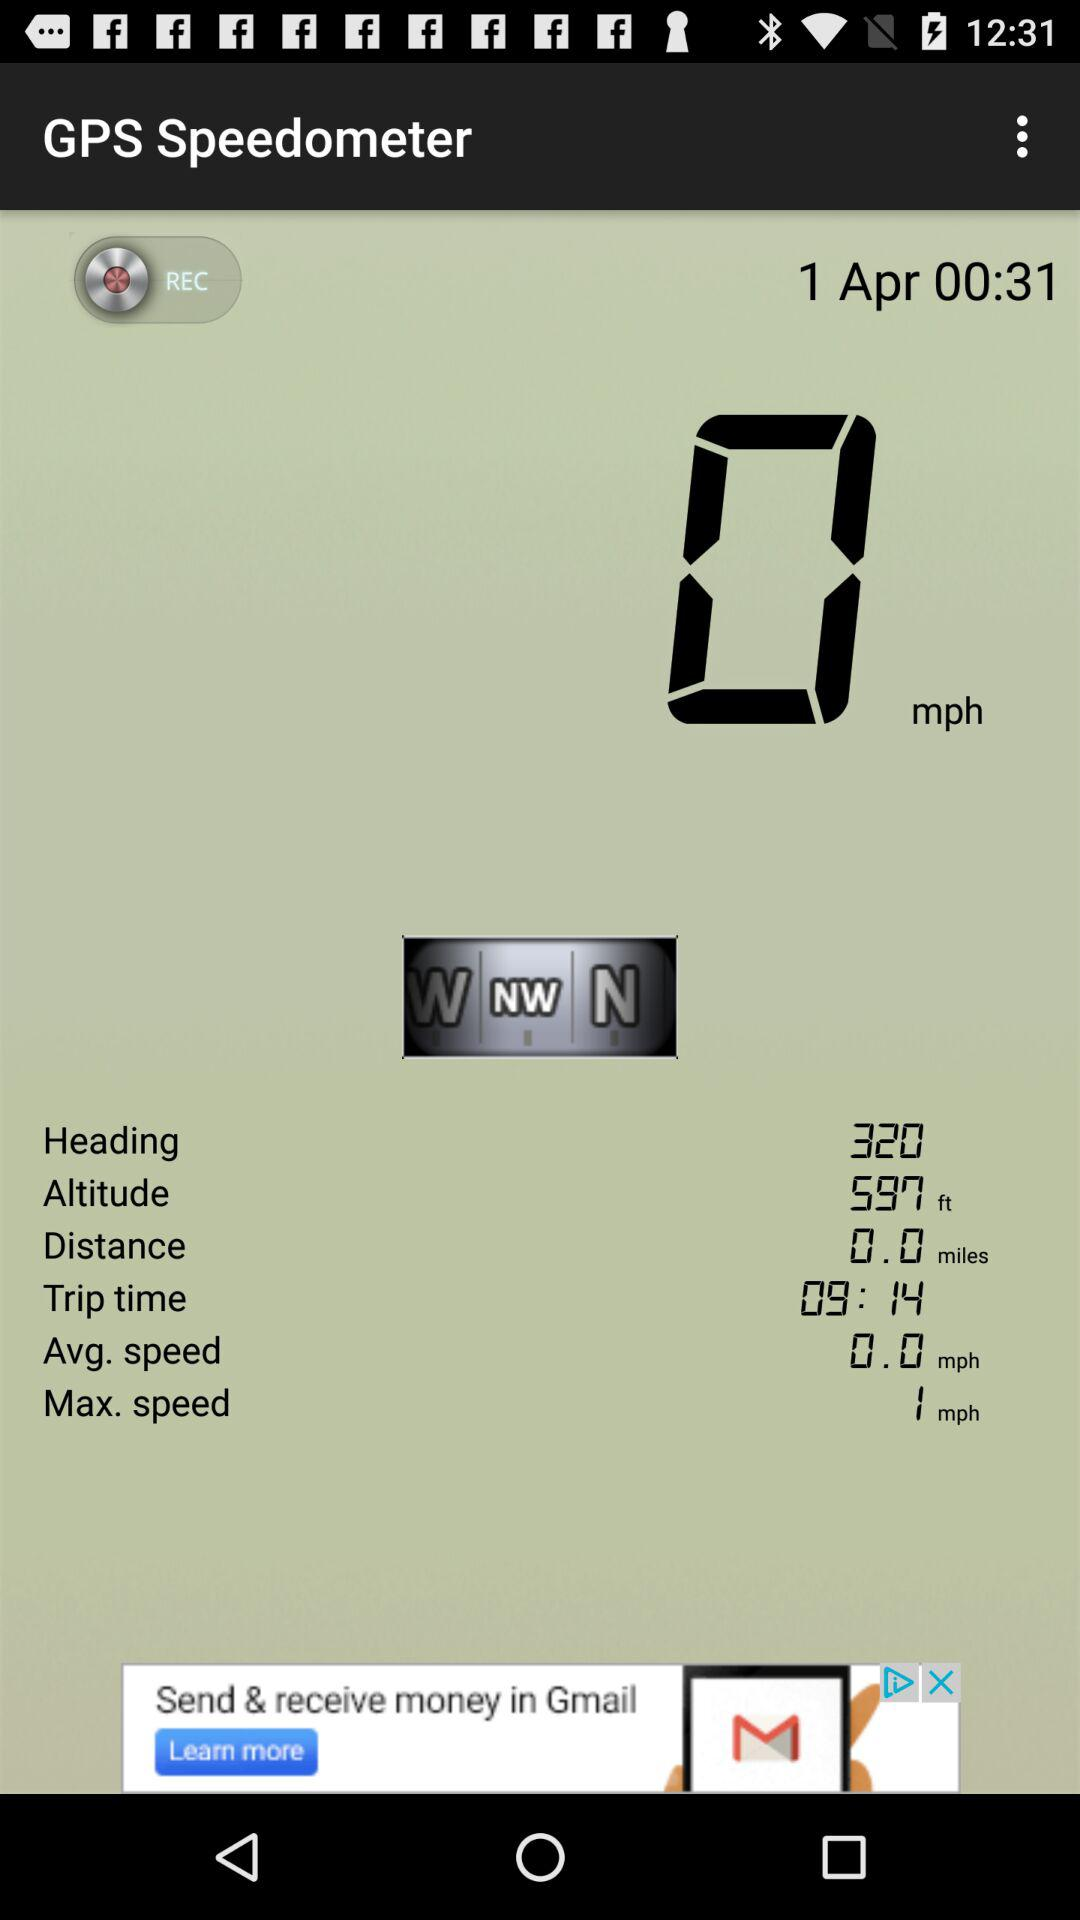What is the shown time and date? The shown time and date are 00:31 and April 1, respectively. 